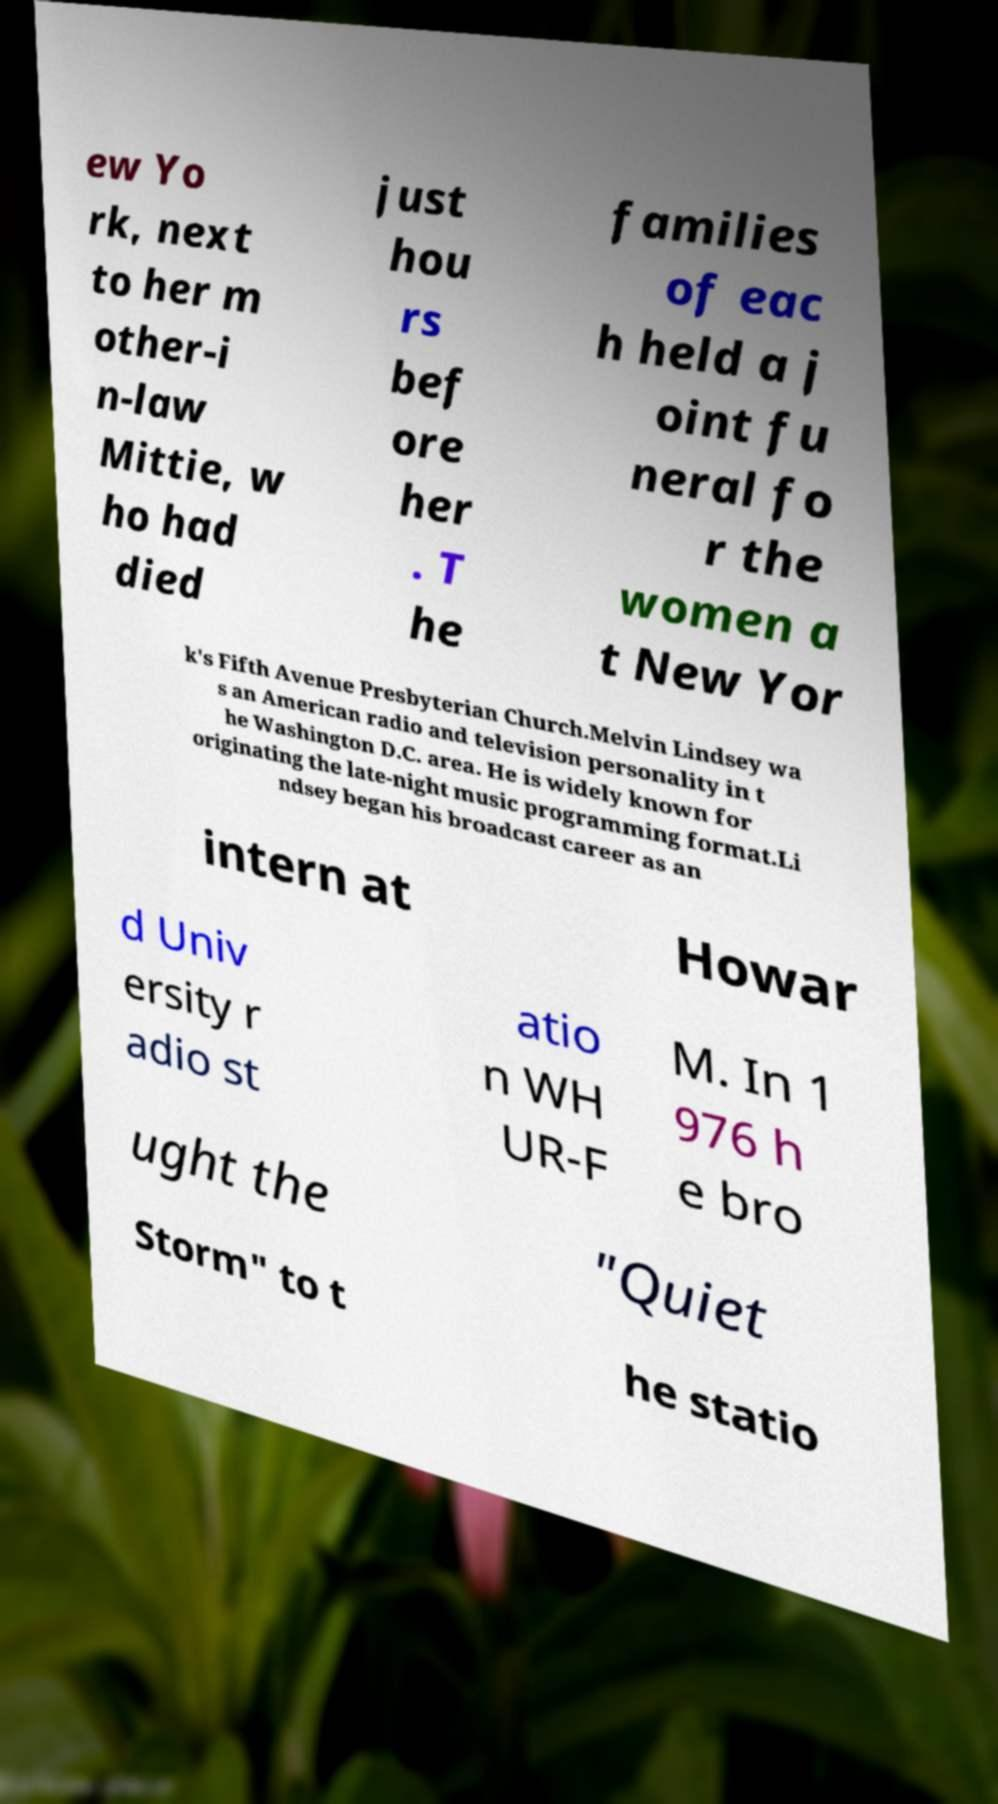Could you extract and type out the text from this image? ew Yo rk, next to her m other-i n-law Mittie, w ho had died just hou rs bef ore her . T he families of eac h held a j oint fu neral fo r the women a t New Yor k's Fifth Avenue Presbyterian Church.Melvin Lindsey wa s an American radio and television personality in t he Washington D.C. area. He is widely known for originating the late-night music programming format.Li ndsey began his broadcast career as an intern at Howar d Univ ersity r adio st atio n WH UR-F M. In 1 976 h e bro ught the "Quiet Storm" to t he statio 